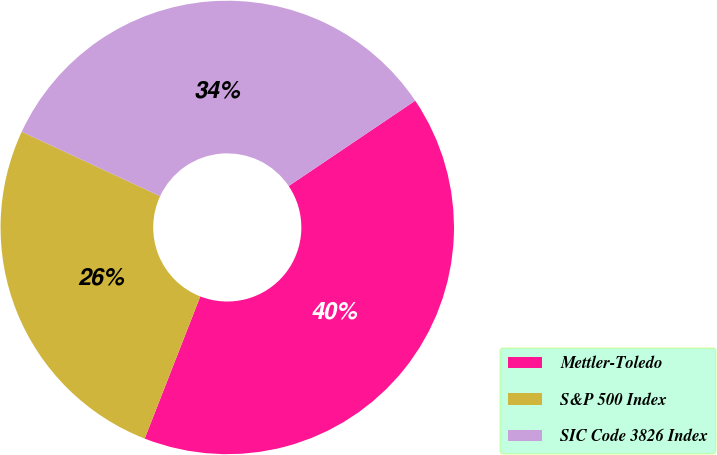Convert chart to OTSL. <chart><loc_0><loc_0><loc_500><loc_500><pie_chart><fcel>Mettler-Toledo<fcel>S&P 500 Index<fcel>SIC Code 3826 Index<nl><fcel>40.38%<fcel>26.0%<fcel>33.62%<nl></chart> 